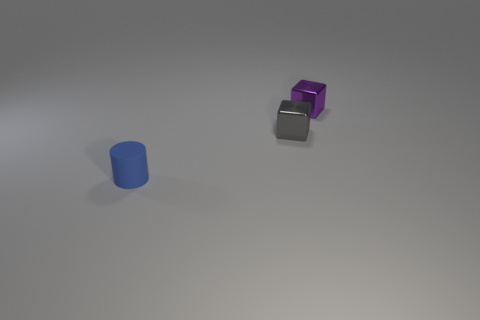Add 2 large cyan metallic cylinders. How many large cyan metallic cylinders exist? 2 Add 2 small blue cylinders. How many objects exist? 5 Subtract 0 brown balls. How many objects are left? 3 Subtract all cubes. How many objects are left? 1 Subtract 1 cubes. How many cubes are left? 1 Subtract all blue blocks. Subtract all gray spheres. How many blocks are left? 2 Subtract all green cylinders. How many green blocks are left? 0 Subtract all small things. Subtract all large purple metallic cylinders. How many objects are left? 0 Add 1 matte things. How many matte things are left? 2 